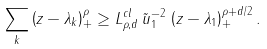<formula> <loc_0><loc_0><loc_500><loc_500>\sum _ { k } \left ( z - \lambda _ { k } \right ) _ { + } ^ { \rho } \geq L _ { \rho , d } ^ { c l } \, { \tilde { u } _ { 1 } } ^ { - 2 } \, \left ( z - \lambda _ { 1 } \right ) _ { + } ^ { \rho + d / 2 } .</formula> 